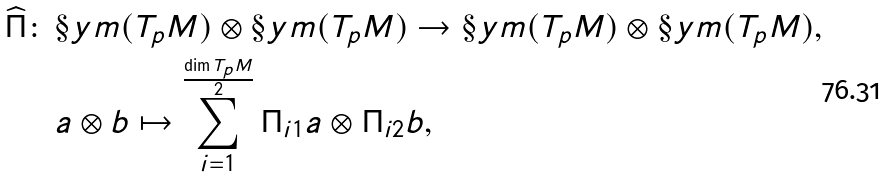<formula> <loc_0><loc_0><loc_500><loc_500>\widehat { \Pi } \colon \, & \S y m ( T _ { p } M ) \otimes \S y m ( T _ { p } M ) \rightarrow \S y m ( T _ { p } M ) \otimes \S y m ( T _ { p } M ) , \\ & a \otimes b \mapsto \sum _ { i = 1 } ^ { \frac { \dim T _ { p } M } { 2 } } \Pi _ { i 1 } a \otimes \Pi _ { i 2 } b ,</formula> 